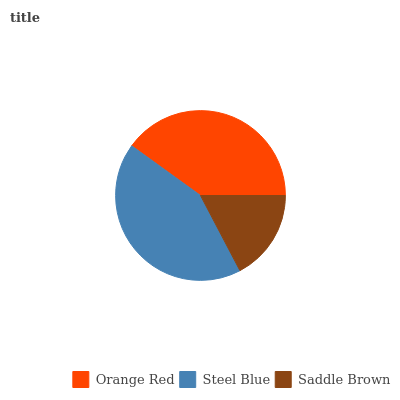Is Saddle Brown the minimum?
Answer yes or no. Yes. Is Steel Blue the maximum?
Answer yes or no. Yes. Is Steel Blue the minimum?
Answer yes or no. No. Is Saddle Brown the maximum?
Answer yes or no. No. Is Steel Blue greater than Saddle Brown?
Answer yes or no. Yes. Is Saddle Brown less than Steel Blue?
Answer yes or no. Yes. Is Saddle Brown greater than Steel Blue?
Answer yes or no. No. Is Steel Blue less than Saddle Brown?
Answer yes or no. No. Is Orange Red the high median?
Answer yes or no. Yes. Is Orange Red the low median?
Answer yes or no. Yes. Is Steel Blue the high median?
Answer yes or no. No. Is Saddle Brown the low median?
Answer yes or no. No. 